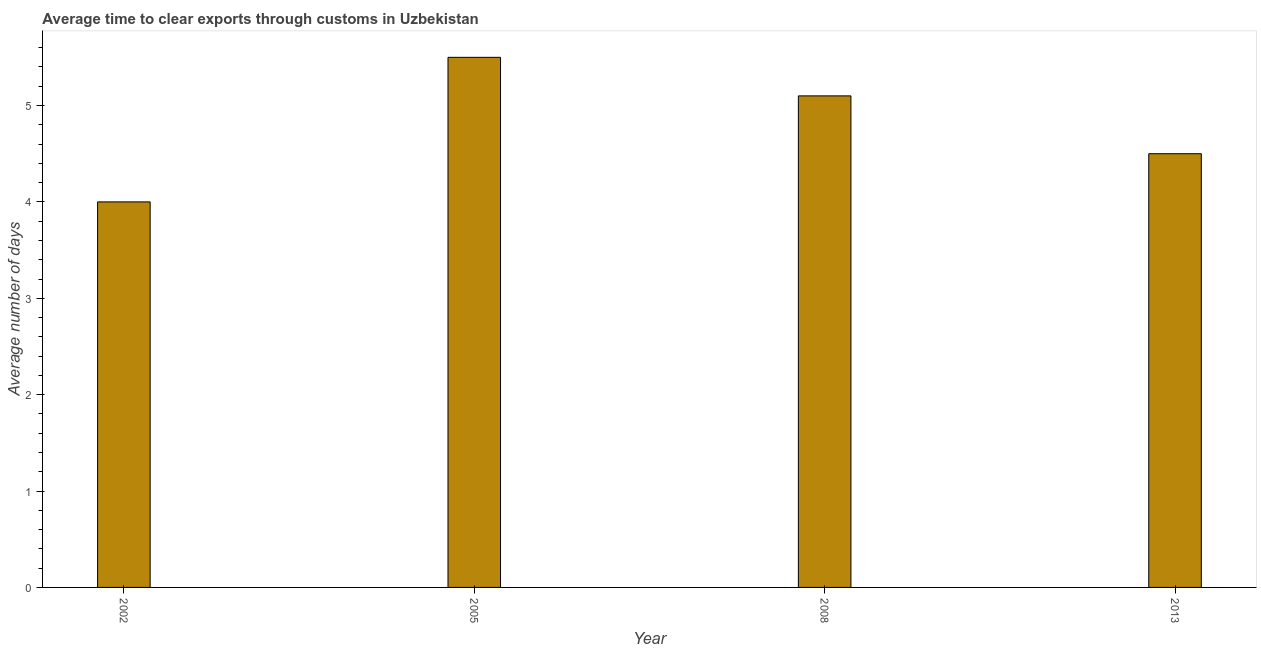Does the graph contain grids?
Make the answer very short. No. What is the title of the graph?
Make the answer very short. Average time to clear exports through customs in Uzbekistan. What is the label or title of the X-axis?
Offer a terse response. Year. What is the label or title of the Y-axis?
Provide a succinct answer. Average number of days. Across all years, what is the maximum time to clear exports through customs?
Provide a short and direct response. 5.5. Across all years, what is the minimum time to clear exports through customs?
Offer a very short reply. 4. What is the sum of the time to clear exports through customs?
Your response must be concise. 19.1. What is the average time to clear exports through customs per year?
Offer a terse response. 4.78. What is the median time to clear exports through customs?
Your response must be concise. 4.8. Do a majority of the years between 2008 and 2013 (inclusive) have time to clear exports through customs greater than 0.4 days?
Offer a very short reply. Yes. What is the ratio of the time to clear exports through customs in 2005 to that in 2013?
Your answer should be compact. 1.22. Is the time to clear exports through customs in 2002 less than that in 2013?
Provide a short and direct response. Yes. Is the difference between the time to clear exports through customs in 2005 and 2008 greater than the difference between any two years?
Keep it short and to the point. No. What is the difference between the highest and the second highest time to clear exports through customs?
Provide a short and direct response. 0.4. Is the sum of the time to clear exports through customs in 2008 and 2013 greater than the maximum time to clear exports through customs across all years?
Offer a very short reply. Yes. How many bars are there?
Offer a very short reply. 4. Are all the bars in the graph horizontal?
Provide a short and direct response. No. What is the difference between two consecutive major ticks on the Y-axis?
Your response must be concise. 1. What is the Average number of days in 2005?
Keep it short and to the point. 5.5. What is the Average number of days in 2008?
Your response must be concise. 5.1. What is the Average number of days in 2013?
Provide a succinct answer. 4.5. What is the difference between the Average number of days in 2002 and 2005?
Your response must be concise. -1.5. What is the difference between the Average number of days in 2002 and 2008?
Keep it short and to the point. -1.1. What is the difference between the Average number of days in 2005 and 2013?
Make the answer very short. 1. What is the ratio of the Average number of days in 2002 to that in 2005?
Make the answer very short. 0.73. What is the ratio of the Average number of days in 2002 to that in 2008?
Offer a very short reply. 0.78. What is the ratio of the Average number of days in 2002 to that in 2013?
Make the answer very short. 0.89. What is the ratio of the Average number of days in 2005 to that in 2008?
Provide a short and direct response. 1.08. What is the ratio of the Average number of days in 2005 to that in 2013?
Make the answer very short. 1.22. What is the ratio of the Average number of days in 2008 to that in 2013?
Your response must be concise. 1.13. 